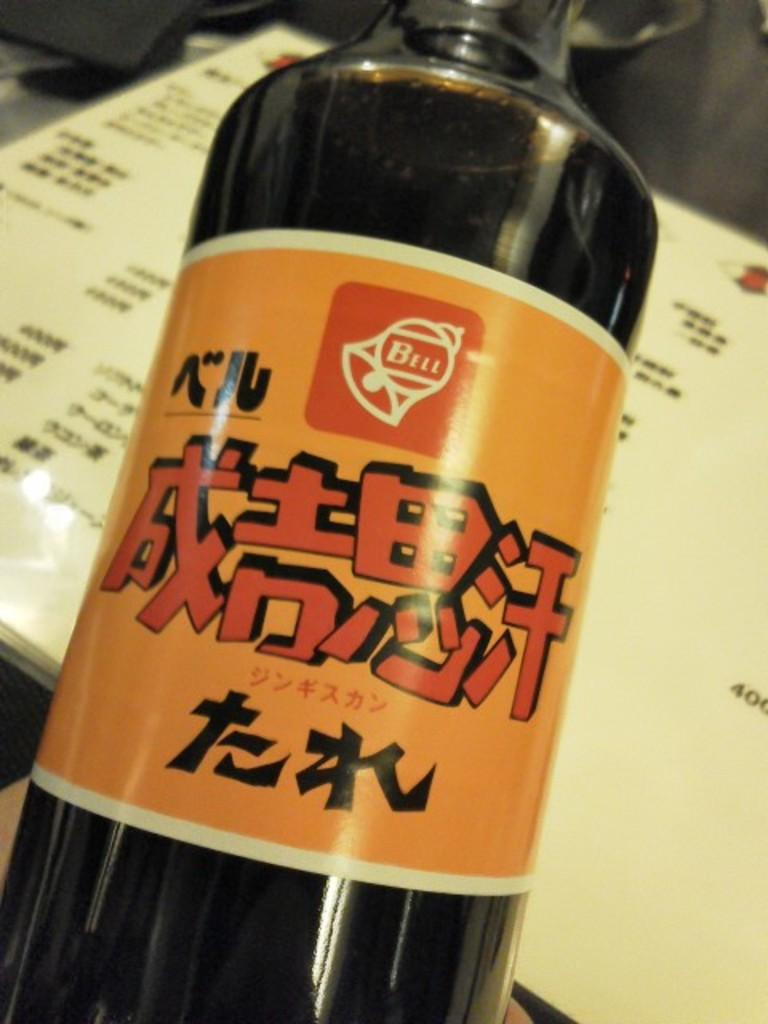<image>
Offer a succinct explanation of the picture presented. A bottle of dark colored liquid with an orange label with Asian text from Bell. 